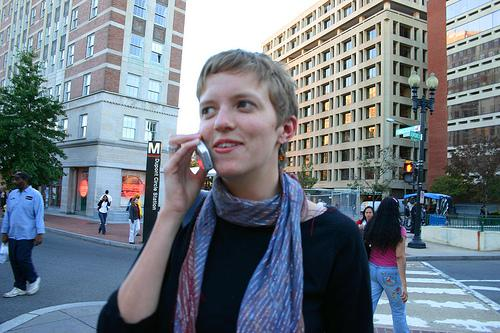Describe the appearance and activity of the primary subject in the image. A short blonde-haired woman is using a silver cell phone in her hand while crossing the street on a busy sidewalk. Mention the key elements of the image, focusing on the main subject and their surroundings. A lady with a blue print scarf around her neck is talking on a cell phone with red lipstick, among street signs, lamp posts, and people walking. Elaborate on the primary subject's appearance and their current action in the image. A woman with red lipstick, wearing a scarf around her neck, is talking on a cell phone as she navigates through a busy pedestrian area. Provide a brief overview of the scene depicted in the image. A young woman with short hair is talking on her cell phone, while crossing a street downtown on a busy sidewalk with a traffic light indicating not to walk. Summarize the main subject's appearance and their action in the image. A girl with short hair is using a grey cell phone while walking on a brick sidewalk along a busy street. Provide a concise description of the main subject's activity and surrounding environment. A young woman is engaged in a phone call while walking in a bustling city atmosphere with street signs, lamp posts, and pedestrians. Identify the prominent object in the image along with its color. The prominent object is a cell phone held by a girl, which is grey in color. Detail the main subject in the image and their interaction with the environment. A young woman with a blue scarf and red lipstick is communicating on a cell phone as she strolls amidst pedestrians, street signs, and traffic lights. Describe the central figure in the image along with their ongoing activity. A short-haired lady on her grey cell phone is walking on a busy street, amidst a vibrant cityscape with various urban elements. Describe the primary action being captured in the image and the location setting. A woman in a pink shirt is walking across a street at a crosswalk, in a crowded downtown area with a tall building on the corner. Is the subway sign at X:136 Y:138 green in color? The object at this position is "sign for subway station," but there's no mention of the color green. Confirm if the building at X:78 Y:5 is short and wide. The object at this position is "the building is tall," not short and wide. Verify if there is a woman with short hair at X:357 Y:190. There's "a woman with long hair" at this position, not short hair. Check if there's a man with a red scarf at X:95 Y:49? The object at this position is "a lady with a scarf around her neck," not a man with a red scarf. Find a tree with purple leaves at X:0 Y:37. The object at this position is "a tree in the city," but there is no mention of purple leaves. Does the girl at X:147 Y:42 has brown lipstick on? The object at this position is "girl on cell phone," but there's no mention of her lipstick color. Is there a gentleman with short hair at X:188 Y:45? The object mentioned is "a girl with short hair" and not a gentleman. Did the traffic light at X:405 Y:165 turn green? The object at this position is "the traffic light is amber in color," not green. Find a dog walking on the sidewalk at X:94 Y:185. There are "people walking on sidewalk" at this position, not a dog. Can you see a blue cell phone at X:184 Y:134? The information provided says "cell phone," but there's no mention of the color blue. 